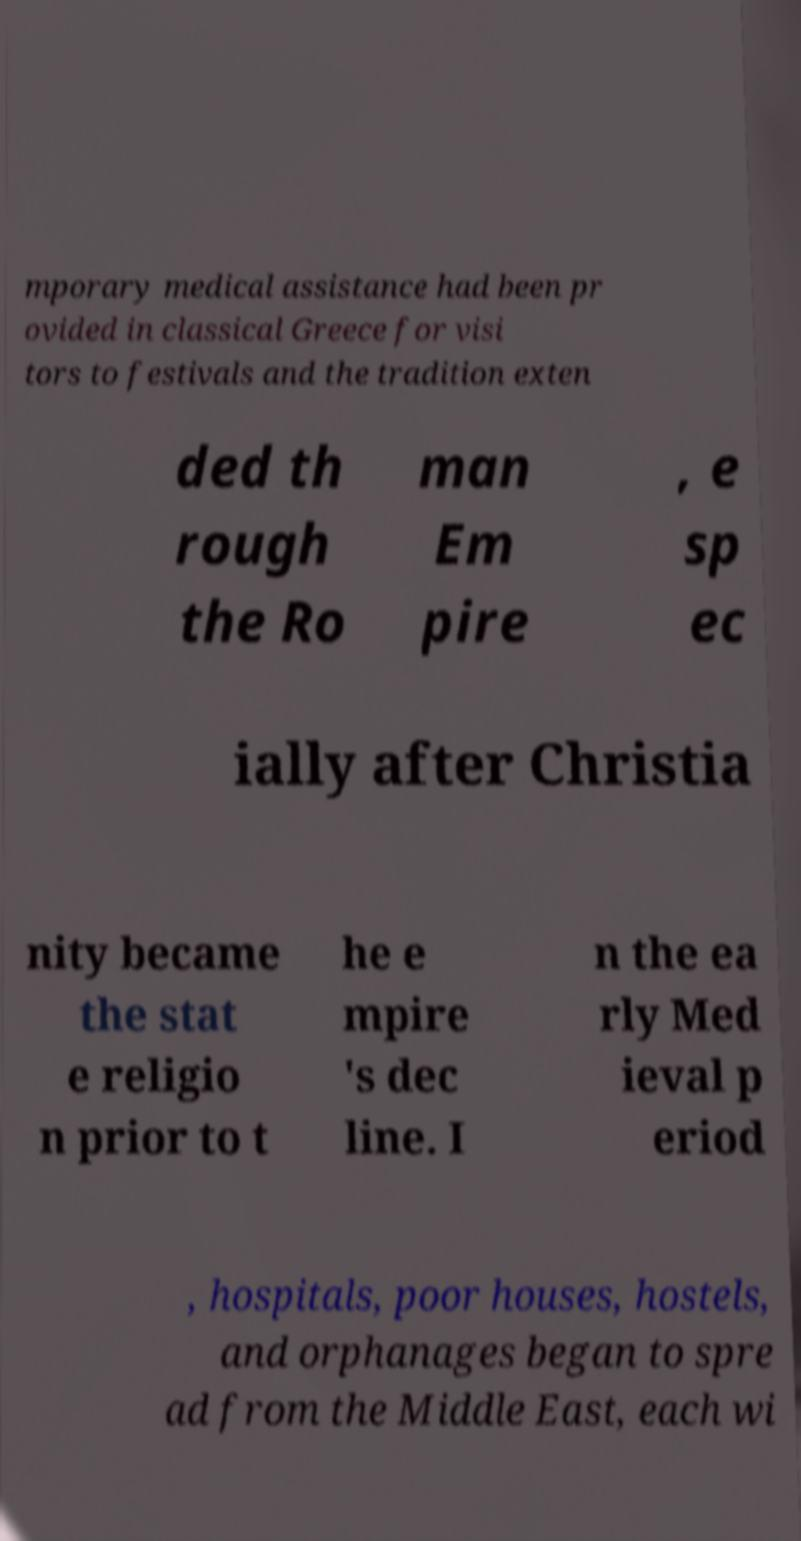I need the written content from this picture converted into text. Can you do that? mporary medical assistance had been pr ovided in classical Greece for visi tors to festivals and the tradition exten ded th rough the Ro man Em pire , e sp ec ially after Christia nity became the stat e religio n prior to t he e mpire 's dec line. I n the ea rly Med ieval p eriod , hospitals, poor houses, hostels, and orphanages began to spre ad from the Middle East, each wi 